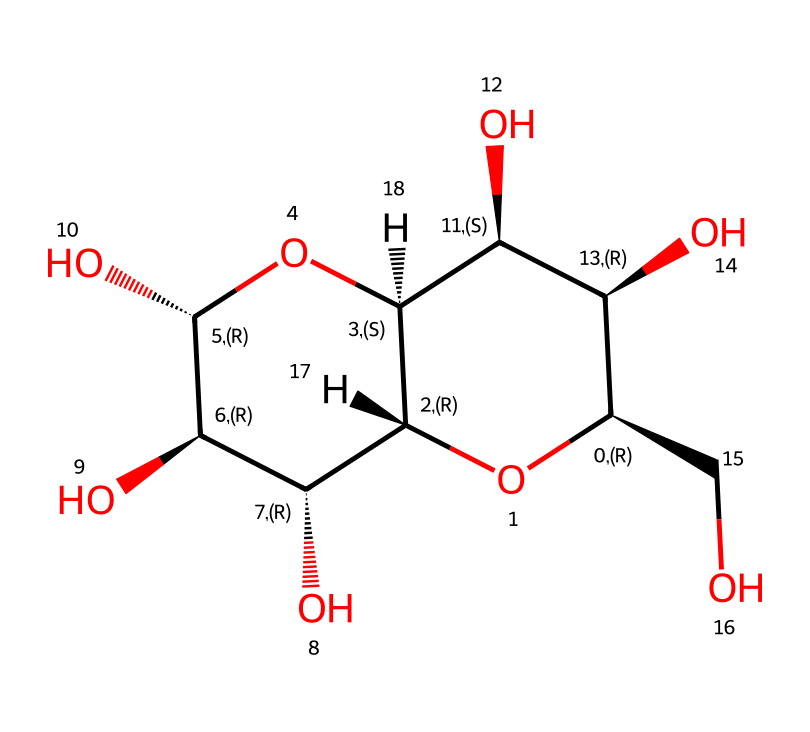what is the main component of the structure represented by this SMILES? The SMILES representation shows a polysaccharide structure, specifically cellulose, which is a major component in the cell wall of plants and is responsible for the structural integrity in paper and parchment.
Answer: cellulose how many oxygen atoms are in the structure? By analyzing the SMILES representation, we can count the oxygen atoms, which appear in the structure multiple times, specifically in the glycosidic linkages and hydroxyl groups. There are six oxygen atoms present.
Answer: six what type of chemical bond predominantly links the glucose units in this structure? In the structure represented by the SMILES code, the predominant type of chemical bond is the glycosidic bond, which forms between the hydroxyl groups of the glucose units. This linkage is specifically a beta-1,4 glycosidic bond.
Answer: glycosidic bond how many carbon atoms are present in this structure? By carefully examining the SMILES representation, we can identify the carbon atoms. There are six carbon atoms within the cyclic and linear portions of the structure.
Answer: six what term describes this compound's function in Renaissance manuscripts? This compound primarily provides structural support and strength to the manuscripts, allowing them to withstand handling while being used as writing surfaces; the term for this function is mechanical support.
Answer: mechanical support which type of carbohydrate does this structure represent? The structure corresponds to a polysaccharide due to its large and repeating unit of smaller sugar molecules, specifically forming a polymer chain of glucose units linked together.
Answer: polysaccharide what type of linkages occur between the repeating units of this carbohydrate? The chemical structure illustrates that it has beta-1,4 linkages between the repeating glucose units, which is characteristic of cellulose and is responsible for its rigidity.
Answer: beta-1,4 linkages 